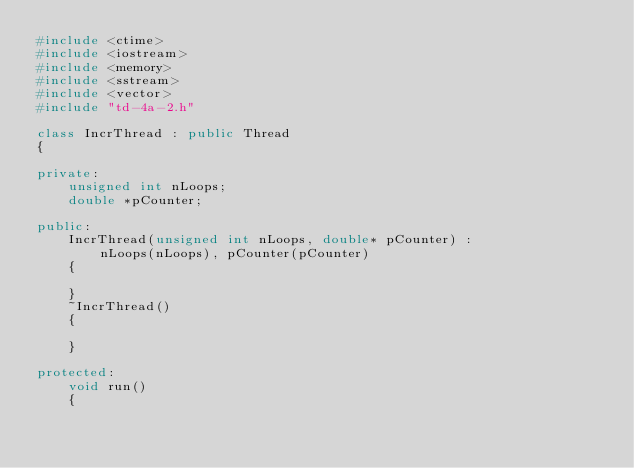Convert code to text. <code><loc_0><loc_0><loc_500><loc_500><_C++_>#include <ctime>
#include <iostream>
#include <memory>
#include <sstream>
#include <vector>
#include "td-4a-2.h"

class IncrThread : public Thread
{

private:
    unsigned int nLoops;
    double *pCounter;

public:
    IncrThread(unsigned int nLoops, double* pCounter) :
        nLoops(nLoops), pCounter(pCounter)
    {

    }
    ~IncrThread()
    {

    }

protected:
    void run()
    {</code> 